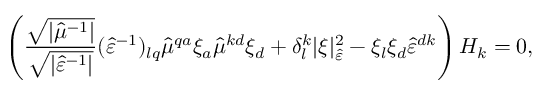Convert formula to latex. <formula><loc_0><loc_0><loc_500><loc_500>\left ( \frac { \sqrt { | \hat { \mu } ^ { - 1 } | } } { \sqrt { | \hat { \varepsilon } ^ { - 1 } | } } ( \hat { \varepsilon } ^ { - 1 } ) _ { l q } \hat { \mu } ^ { q a } \xi _ { a } \hat { \mu } ^ { k d } \xi _ { d } + \delta _ { l } ^ { k } | \xi | _ { \hat { \varepsilon } } ^ { 2 } - \xi _ { l } \xi _ { d } \hat { \varepsilon } ^ { d k } \right ) H _ { k } = 0 ,</formula> 